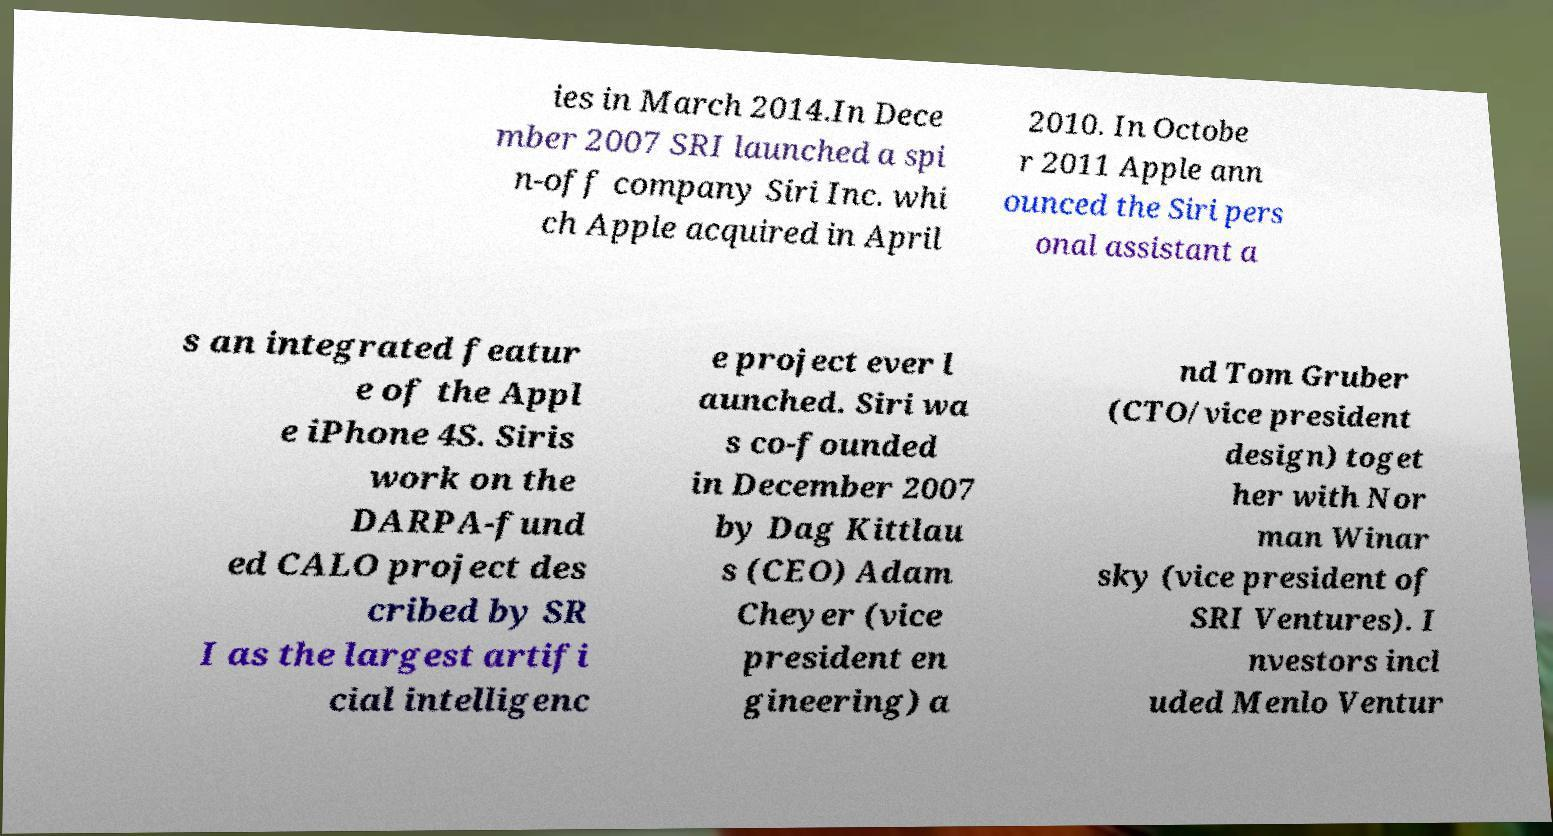What messages or text are displayed in this image? I need them in a readable, typed format. ies in March 2014.In Dece mber 2007 SRI launched a spi n-off company Siri Inc. whi ch Apple acquired in April 2010. In Octobe r 2011 Apple ann ounced the Siri pers onal assistant a s an integrated featur e of the Appl e iPhone 4S. Siris work on the DARPA-fund ed CALO project des cribed by SR I as the largest artifi cial intelligenc e project ever l aunched. Siri wa s co-founded in December 2007 by Dag Kittlau s (CEO) Adam Cheyer (vice president en gineering) a nd Tom Gruber (CTO/vice president design) toget her with Nor man Winar sky (vice president of SRI Ventures). I nvestors incl uded Menlo Ventur 